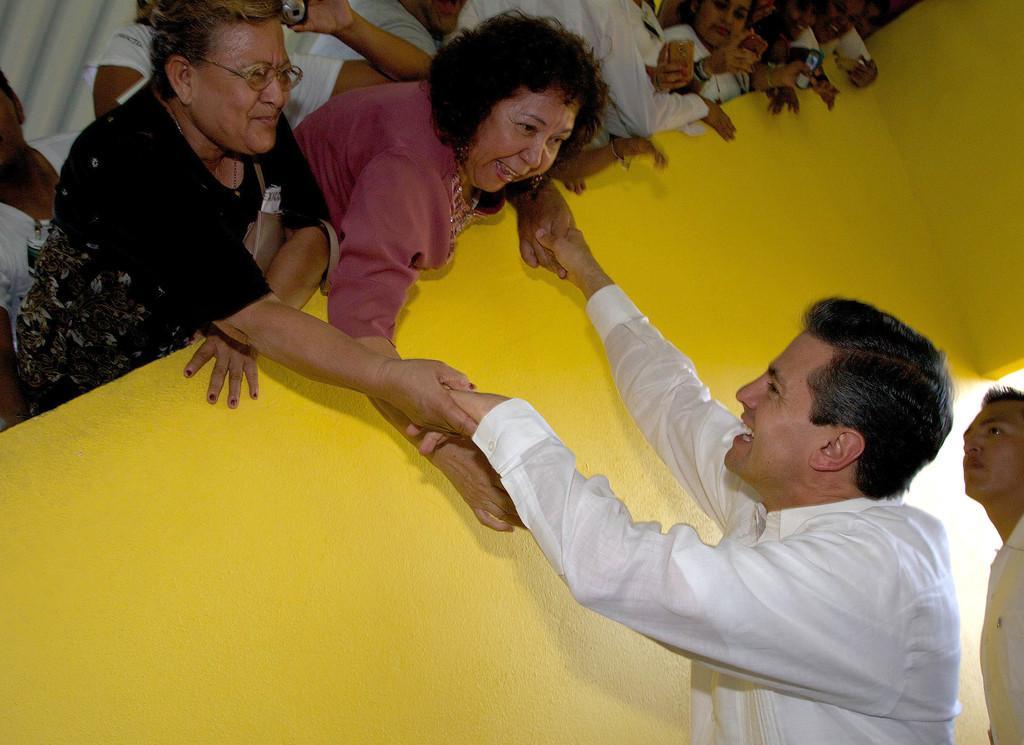Describe this image in one or two sentences. In this image I can see group of people standing. In front the person is wearing white color shirt and the person at left is wearing black color shirt and I can see the wall in yellow color. 